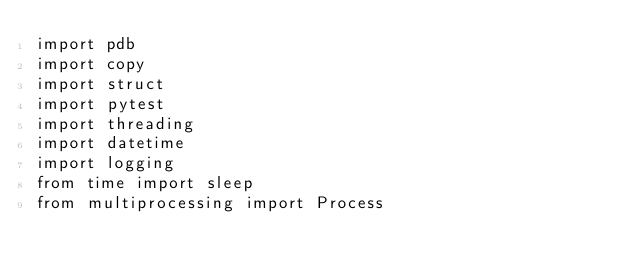Convert code to text. <code><loc_0><loc_0><loc_500><loc_500><_Python_>import pdb
import copy
import struct
import pytest
import threading
import datetime
import logging
from time import sleep
from multiprocessing import Process</code> 